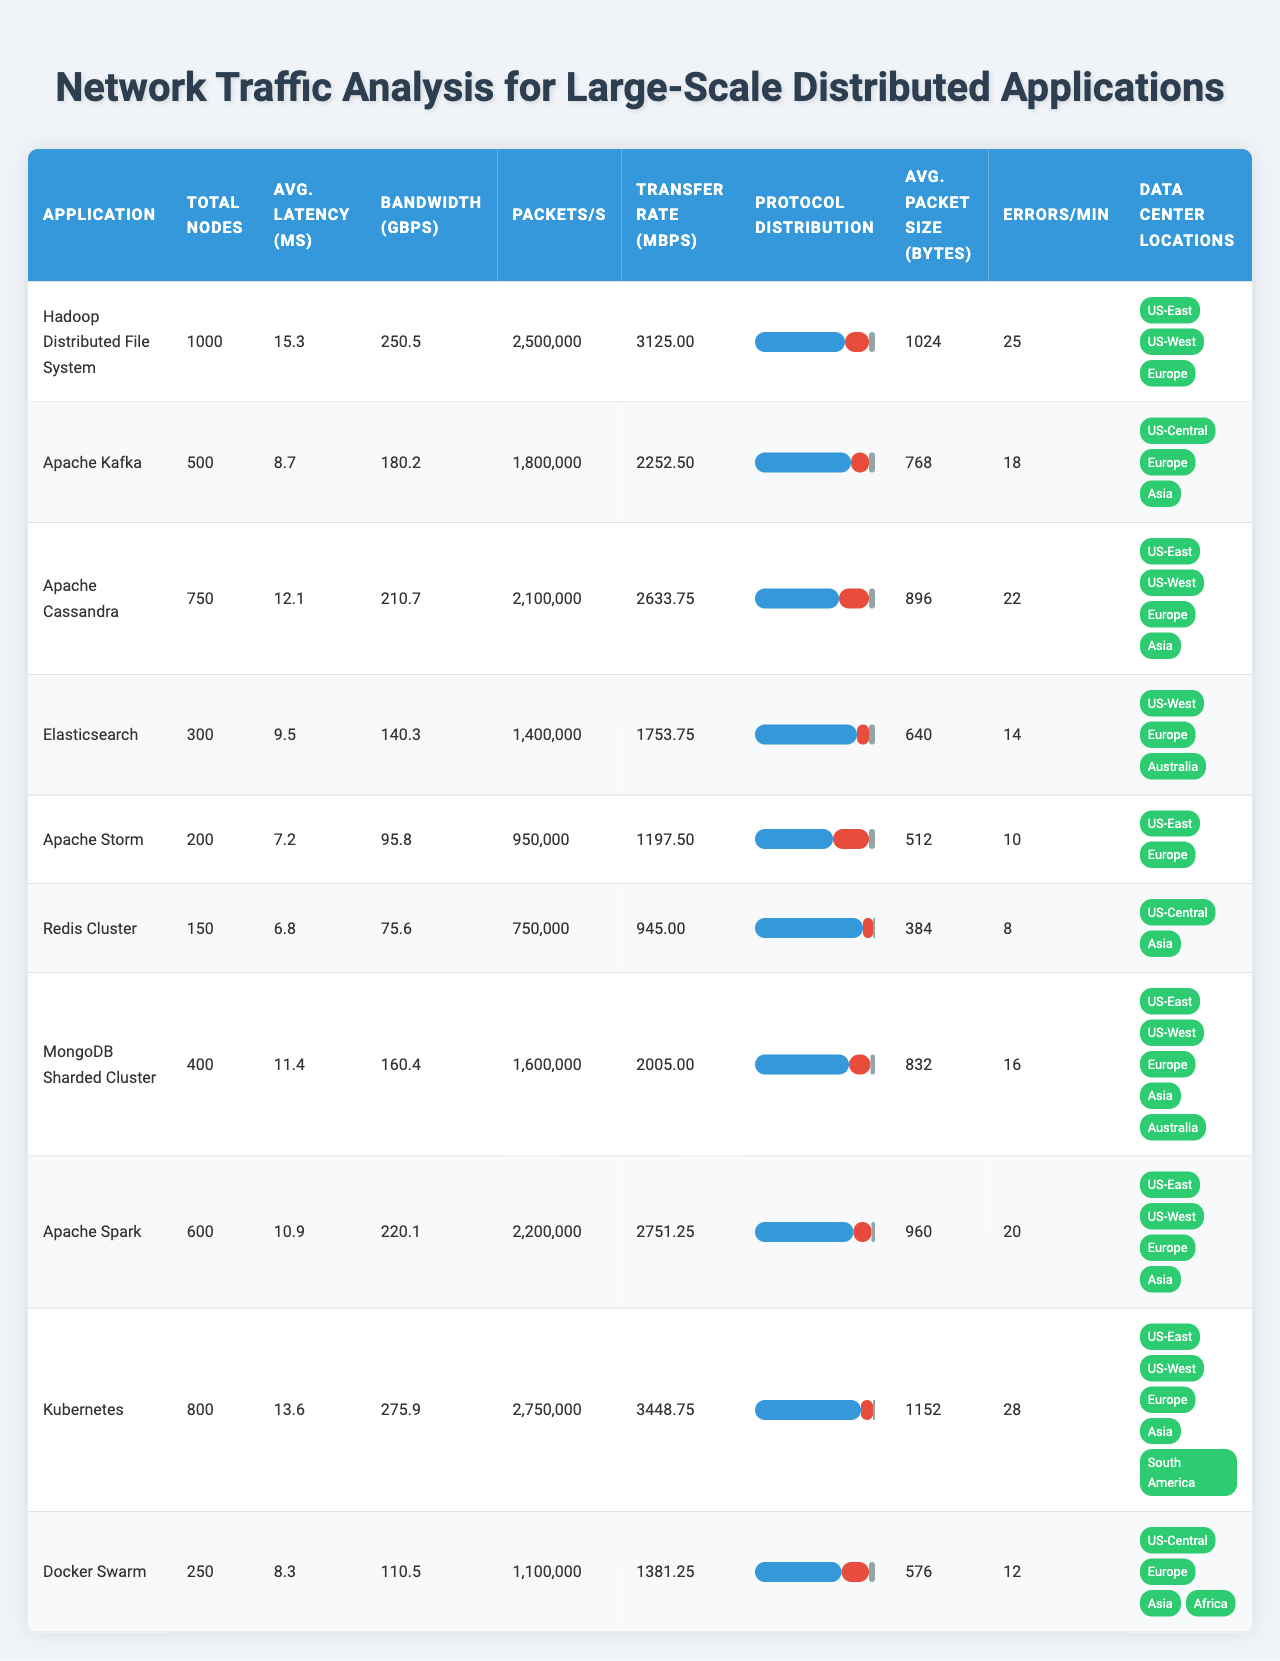What is the average network latency for Apache Kafka? The value for average network latency is provided directly in the table for Apache Kafka, which is listed as 8.7 milliseconds.
Answer: 8.7 ms Which application has the highest total bandwidth usage? By examining the total bandwidth usage column, we can see that Kubernetes has the highest usage at 275.9 Gbps.
Answer: Kubernetes How many total nodes does Elasticsearch have? The table indicates that Elasticsearch has a total of 300 nodes.
Answer: 300 What is the average packet size for MongoDB Sharded Cluster? The table provides the average packet size for MongoDB Sharded Cluster, which is 832 bytes.
Answer: 832 bytes Is the protocol distribution for Apache Storm predominantly TCP? Looking at the table, we see that in Apache Storm, TCP accounts for 65%, which is indeed a majority.
Answer: Yes What is the total sum of network errors per minute for all applications? To find the total sum, we need to add the errors per minute from each application: 25 + 18 + 22 + 14 + 10 + 8 + 16 + 20 + 28 + 12 = 183.
Answer: 183 Which application has the lowest data transfer rate, and what is the value? By checking the data transfer rate, we find that Apache Storm has the lowest transfer rate of 1197.5 Mbps.
Answer: Apache Storm, 1197.5 Mbps Are there more total nodes in Redis Cluster than in Docker Swarm? The table shows that Redis Cluster has 150 total nodes, while Docker Swarm has 250, so Redis Cluster has fewer nodes.
Answer: No What is the difference in average network latency between Hadoop Distributed File System and Apache Storm? We calculate the difference in latency: 15.3 ms (Hadoop) - 7.2 ms (Storm) = 8.1 ms, indicating Hadoop has a higher latency.
Answer: 8.1 ms Which application has the highest packets per second, and what is that number? Looking at the packets per second column, we see that Kubernetes has the highest value at 2,750,000 packets per second.
Answer: Kubernetes, 2,750,000 packets/s What percentage of protocol distribution for TCP does Apache Cassandra have compared to the application with the lowest? Apache Cassandra has 70% TCP distribution, while Redis Cluster has 90%, making Cassandra's percentage 20% lower than Redis.
Answer: 20% lower How many unique data center locations are used by Apache Cassandra? The locations for the data center of Apache Cassandra show 4 unique locations: US-East, US-West, Europe, and Asia.
Answer: 4 locations Which application has the closest average packet size to 900 bytes? Examining the average packet sizes, Apache Cassandra has 896 bytes, which is closest to 900 bytes.
Answer: Apache Cassandra What is the highest number of network errors per minute among the applications? The highest value of network errors per minute is found under the network errors column, which is 28 for Kubernetes.
Answer: 28 errors/min Which application uses the least total bandwidth, and how much is that? The table reveals that Apache Storm has the least total bandwidth usage at 95.8 Gbps.
Answer: Apache Storm, 95.8 Gbps 